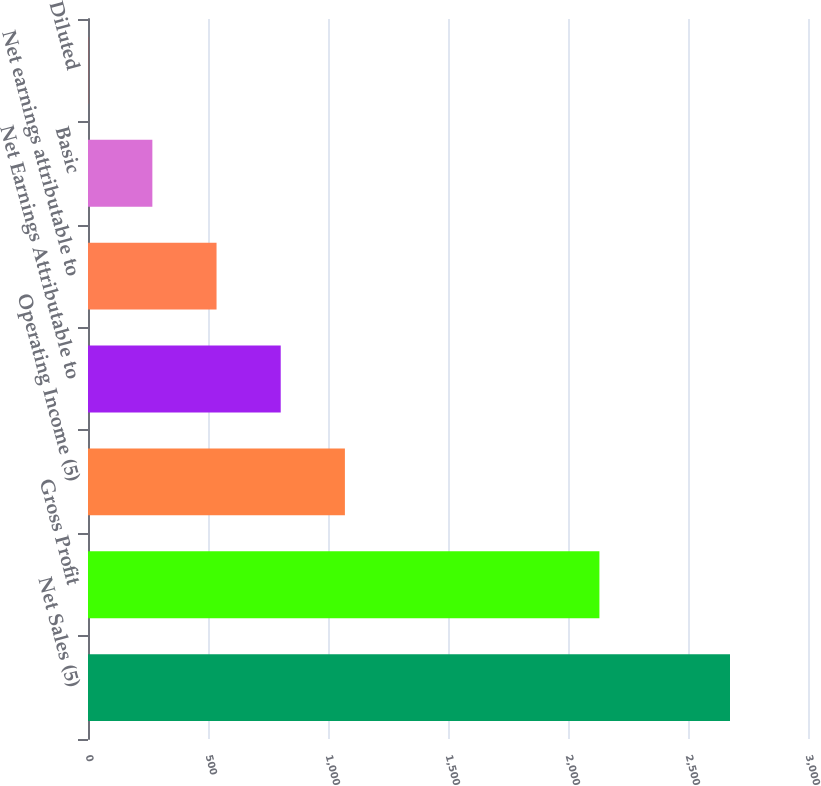Convert chart to OTSL. <chart><loc_0><loc_0><loc_500><loc_500><bar_chart><fcel>Net Sales (5)<fcel>Gross Profit<fcel>Operating Income (5)<fcel>Net Earnings Attributable to<fcel>Net earnings attributable to<fcel>Basic<fcel>Diluted<nl><fcel>2675<fcel>2130.9<fcel>1070.44<fcel>803.02<fcel>535.6<fcel>268.18<fcel>0.76<nl></chart> 